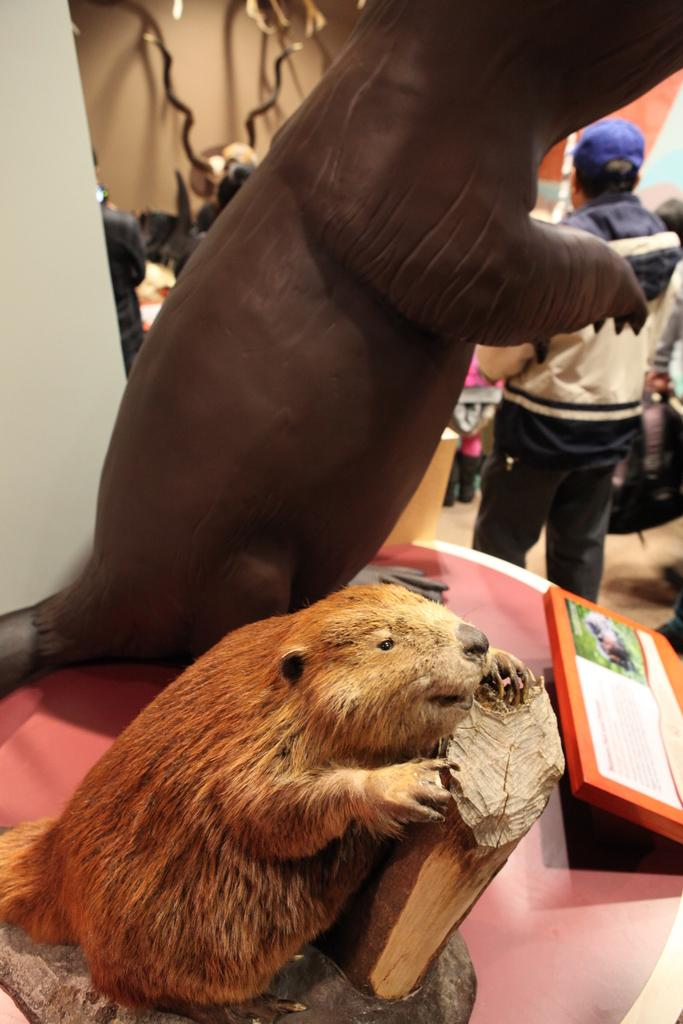What objects are on the table in the image? There are two toys on a table in the image. What can be seen behind the table? There are groups of people visible behind the table, as well as other unspecified things. What type of transport is being traded by the men in the image? There are no men or any reference to trade or transport in the image. 